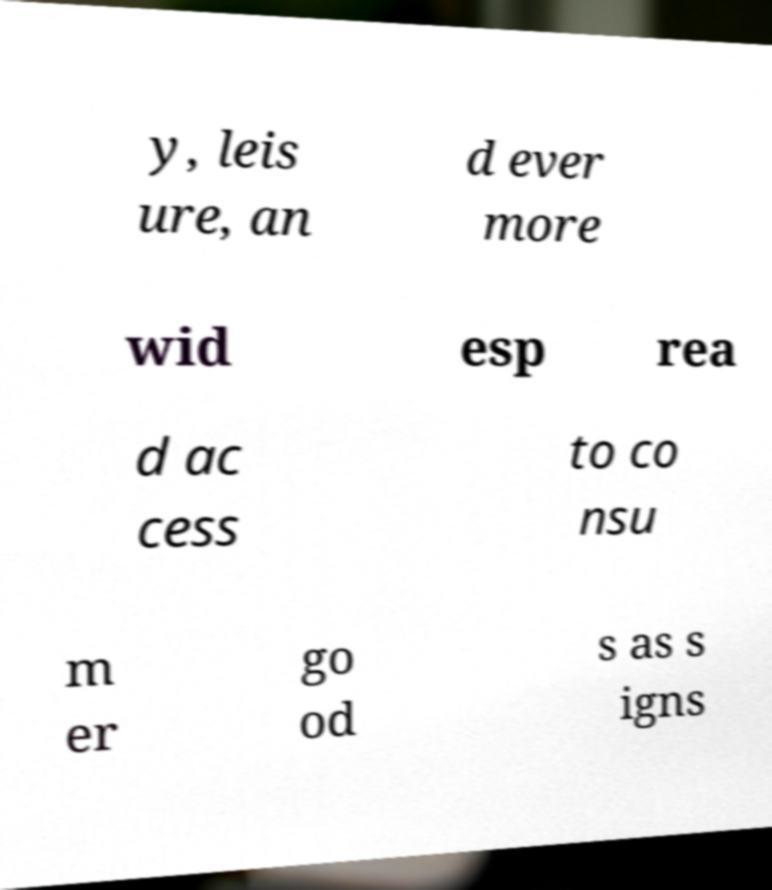There's text embedded in this image that I need extracted. Can you transcribe it verbatim? y, leis ure, an d ever more wid esp rea d ac cess to co nsu m er go od s as s igns 